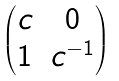Convert formula to latex. <formula><loc_0><loc_0><loc_500><loc_500>\begin{pmatrix} c & 0 \\ 1 & c ^ { - 1 } \end{pmatrix}</formula> 